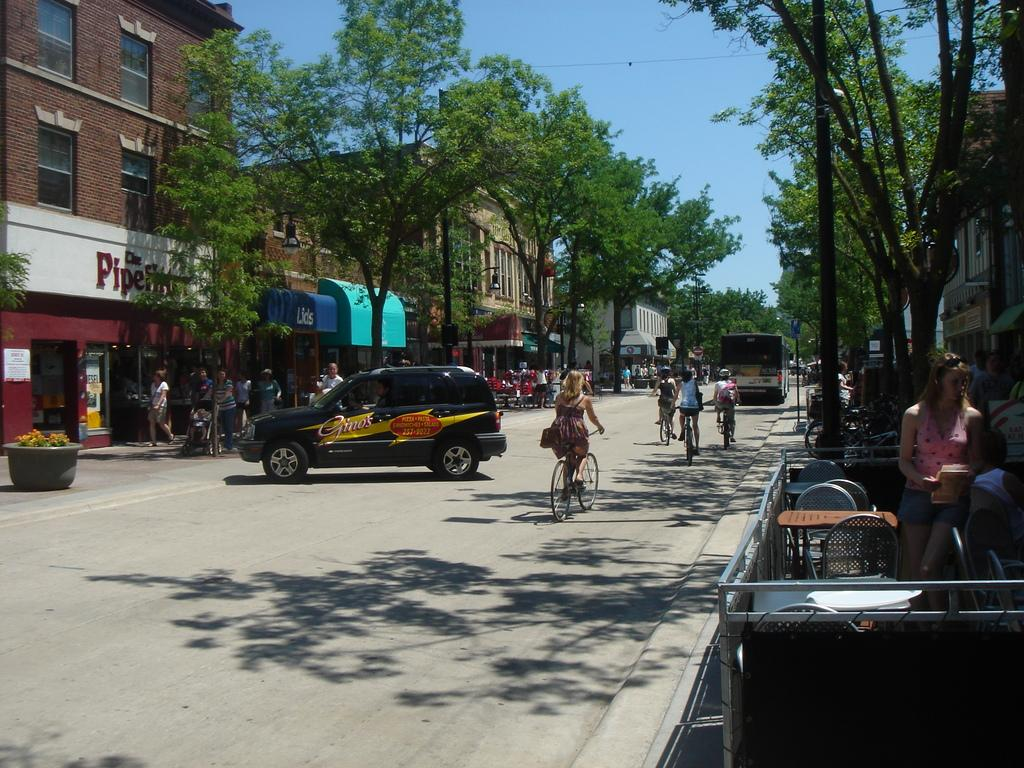<image>
Describe the image concisely. A city street where people are riding bikes past a shop that says The Pipe Fitter. 